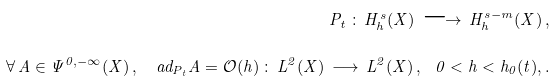<formula> <loc_0><loc_0><loc_500><loc_500>P _ { t } \, \colon \, H ^ { s } _ { h } ( X ) \, \longrightarrow \, H ^ { s - m } _ { h } ( X ) \, , \\ \forall \, A \in \Psi ^ { 0 , - \infty } ( X ) \, , \ \ \ a d _ { P _ { t } } A = { \mathcal { O } } ( h ) \, \colon \, L ^ { 2 } ( X ) \, \longrightarrow \, L ^ { 2 } ( X ) \, , \ \ 0 < h < h _ { 0 } ( t ) , .</formula> 